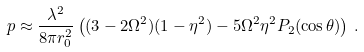Convert formula to latex. <formula><loc_0><loc_0><loc_500><loc_500>p \approx \frac { \lambda ^ { 2 } } { 8 \pi r _ { 0 } ^ { 2 } } \left ( ( 3 - 2 \Omega ^ { 2 } ) ( 1 - \eta ^ { 2 } ) - 5 \Omega ^ { 2 } \eta ^ { 2 } P _ { 2 } ( \cos \theta ) \right ) \, .</formula> 